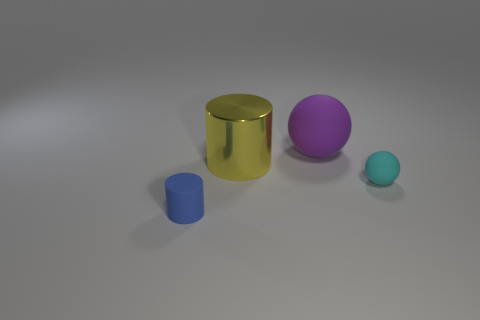How many other blue things have the same size as the blue object?
Make the answer very short. 0. There is a ball that is left of the tiny rubber object right of the yellow metallic object; what is its color?
Offer a terse response. Purple. Are any green metallic things visible?
Offer a very short reply. No. Do the large metallic object and the small blue object have the same shape?
Keep it short and to the point. Yes. There is a cylinder that is in front of the cyan sphere; how many rubber things are in front of it?
Make the answer very short. 0. What number of rubber things are both in front of the large purple matte object and behind the tiny blue thing?
Your answer should be very brief. 1. What number of objects are small blue matte things or things that are behind the tiny blue cylinder?
Your answer should be very brief. 4. What is the size of the cylinder that is the same material as the purple ball?
Provide a succinct answer. Small. What shape is the small object on the left side of the object behind the yellow metallic cylinder?
Provide a short and direct response. Cylinder. What number of yellow objects are either small metallic cubes or tiny cylinders?
Give a very brief answer. 0. 